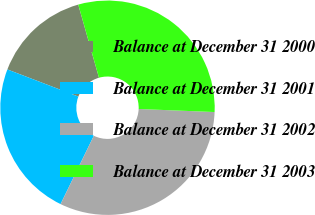Convert chart. <chart><loc_0><loc_0><loc_500><loc_500><pie_chart><fcel>Balance at December 31 2000<fcel>Balance at December 31 2001<fcel>Balance at December 31 2002<fcel>Balance at December 31 2003<nl><fcel>14.79%<fcel>23.6%<fcel>31.57%<fcel>30.04%<nl></chart> 